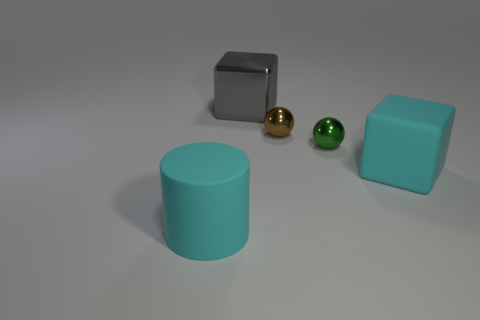Is there a pattern or theme to the arrangement of these objects? The objects don't follow any obvious pattern or theme in their arrangement; they seem to be placed randomly. However, they do showcase a variety of geometric forms and a contrast in colors which might suggest a concept of diversity or variety. Could these objects represent any mathematical concepts? Indeed, these objects could be used to explore concepts of geometry such as shape, volume, and spatial relationships. The spheres and cubes also lend themselves to discussions on symmetry and surface area. 